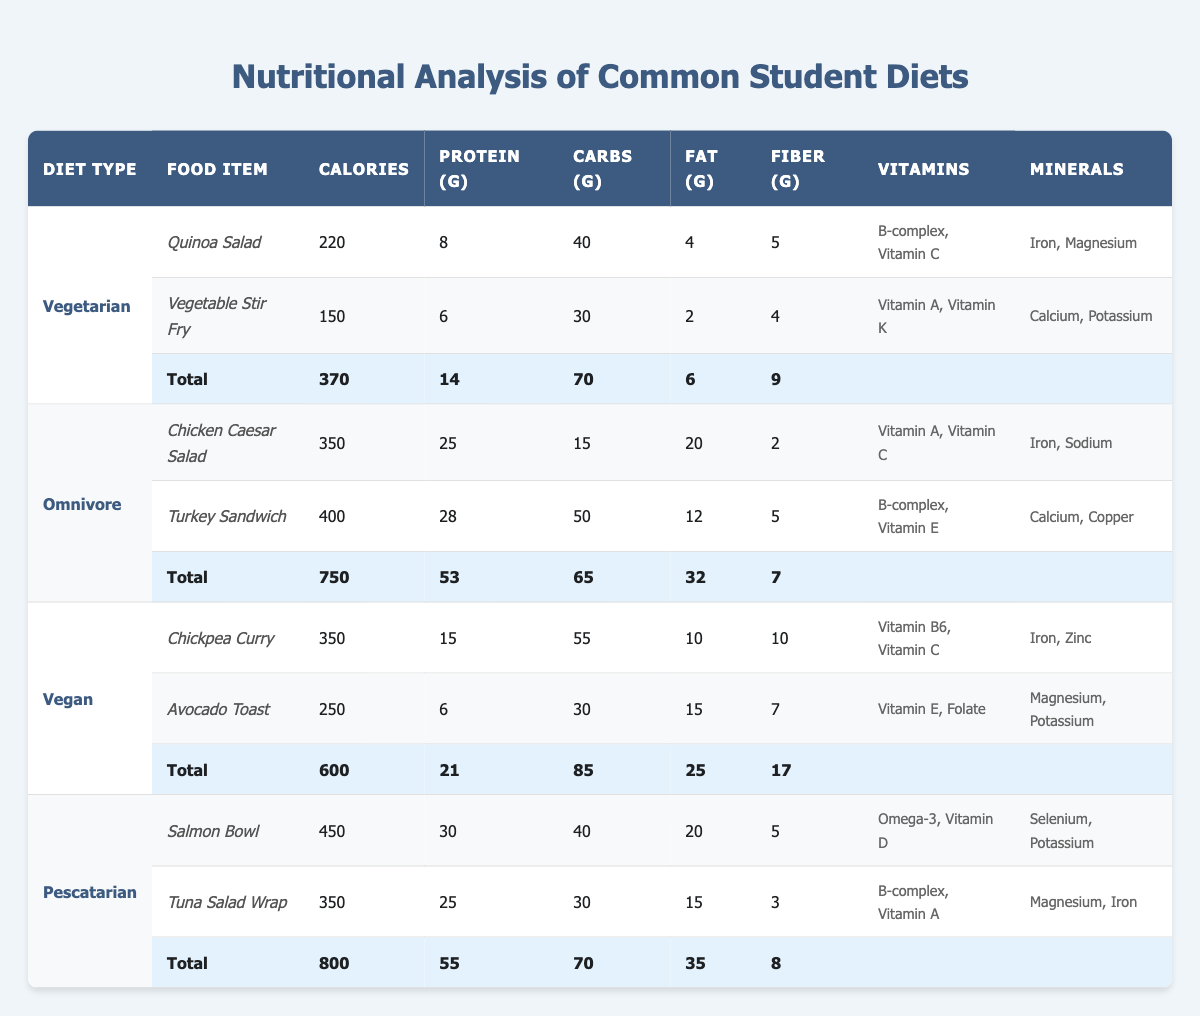What are the total calories in the Vegan diet? According to the table, the Vegan diet has a total of 600 calories, which can be found in the last total row for the Vegan diet type.
Answer: 600 Which diet contains the highest amount of protein? By comparing the total protein values listed for each diet type in the total rows, the Omnivore diet has the highest amount at 53 grams.
Answer: Omnivore Is there any food item in the Vegetarian diet that provides more than 200 calories? Reviewing the calorie counts for the food items under the Vegetarian diet, the Quinoa Salad at 220 calories is above 200. Thus, the answer is yes.
Answer: Yes What is the total amount of fiber in the Pescatarian diet? Looking at the total row for the Pescatarian diet, the fiber amount is listed as 8 grams.
Answer: 8 Which diet has the least total carbohydrates? Evaluating the total carbohydrates in each diet, the Vegetarian diet has the least total at 70 grams compared to the others: Vegan (85g), Omnivore (65g), Pescatarian (70g). Hence, the Omnivore diet is minimal.
Answer: Omnivore Calculate the average calories of the food items in the Omnivore diet. The Omnivore diet includes two food items: Chicken Caesar Salad with 350 calories and Turkey Sandwich with 400 calories. The average is (350 + 400) / 2 = 375.
Answer: 375 Does the Vegan diet provide more fiber than the Vegetarian diet? The total fiber for the Vegan diet is 17 grams, while for the Vegetarian diet, it is 9 grams. Therefore, since 17 is greater than 9, the answer is yes.
Answer: Yes What is the combined fat content of the food items in the Vegetarian diet? Summing the fat content from the individual food items in the Vegetarian diet: Quinoa Salad (4g) and Vegetable Stir Fry (2g), gives a total of 6 grams.
Answer: 6 Which diet has the highest total calories, and what is that number? The total calories for each diet shows Pescatarian at 800 calories, which is higher compared to others: Vegetarian (370), Omnivore (750), Vegan (600).
Answer: Pescatarian, 800 